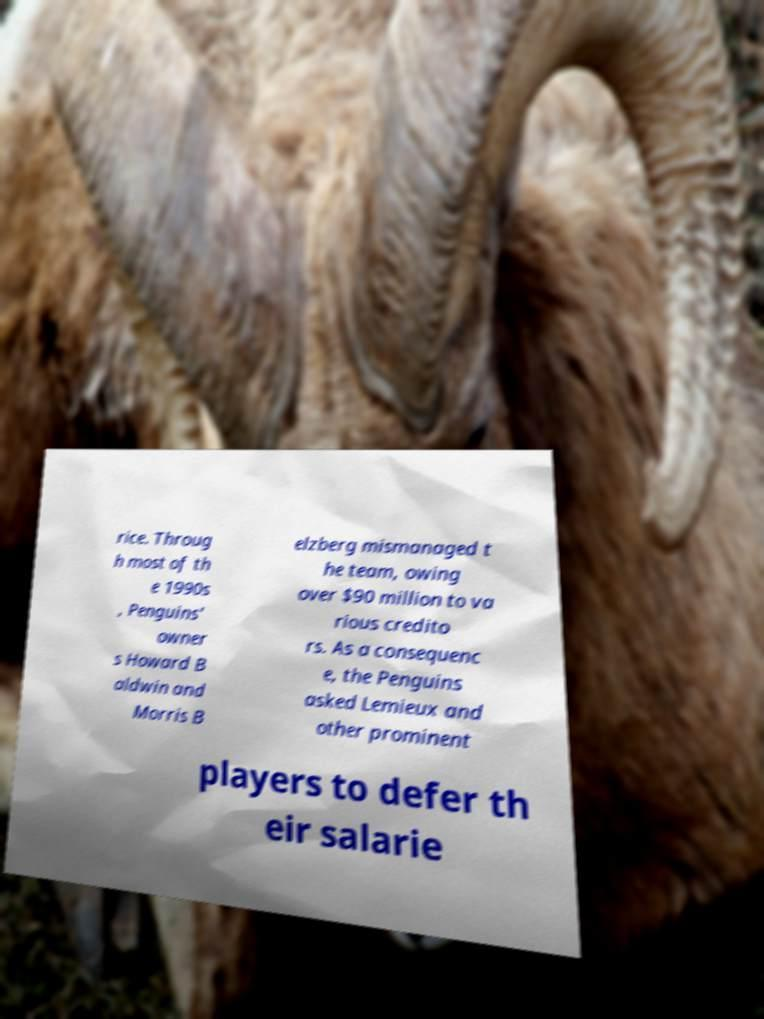What messages or text are displayed in this image? I need them in a readable, typed format. rice. Throug h most of th e 1990s , Penguins' owner s Howard B aldwin and Morris B elzberg mismanaged t he team, owing over $90 million to va rious credito rs. As a consequenc e, the Penguins asked Lemieux and other prominent players to defer th eir salarie 